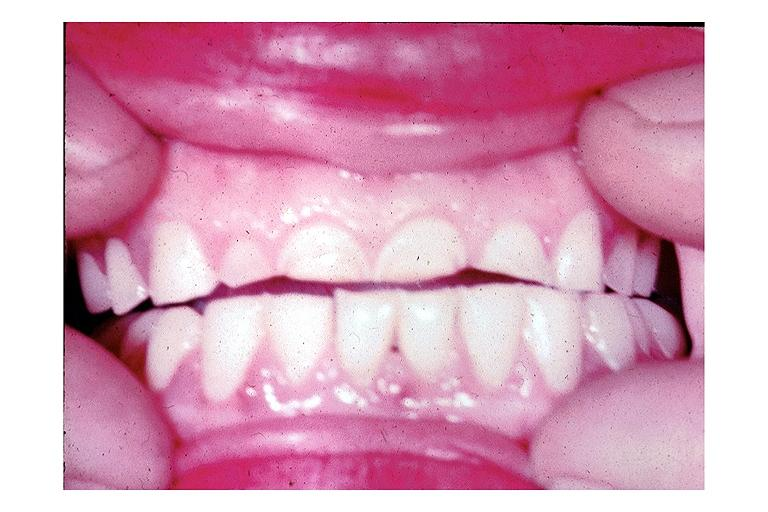does acute inflammation show attrition?
Answer the question using a single word or phrase. No 